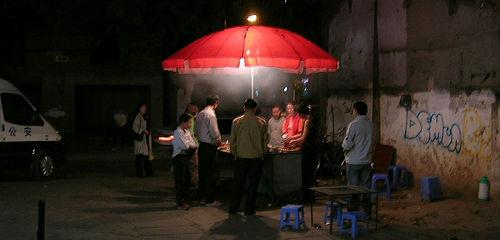What is happening under the umbrella? Please explain your reasoning. food sales. There is a food cart under the umbrella and people are buying and selling food. 